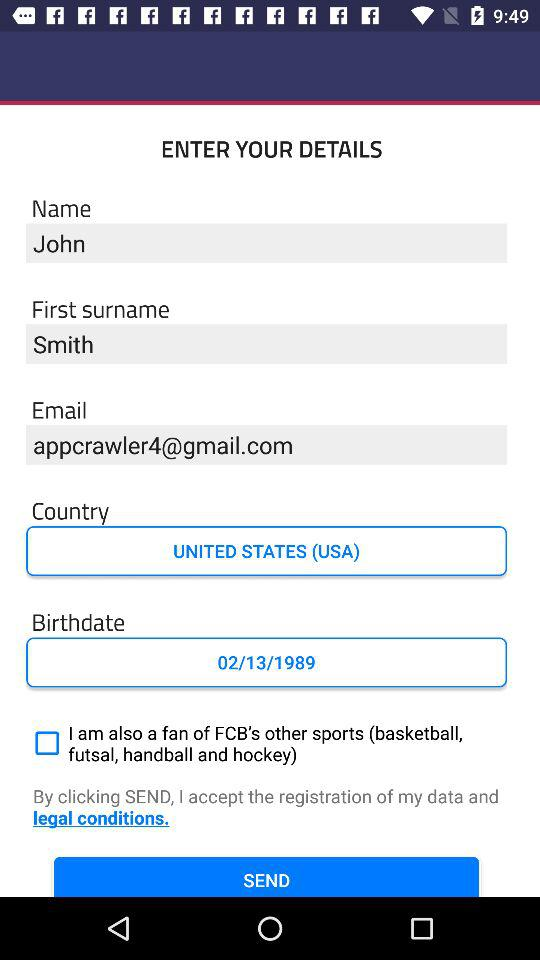What is an email address? An email address is appcrawler4@gmail.com. 